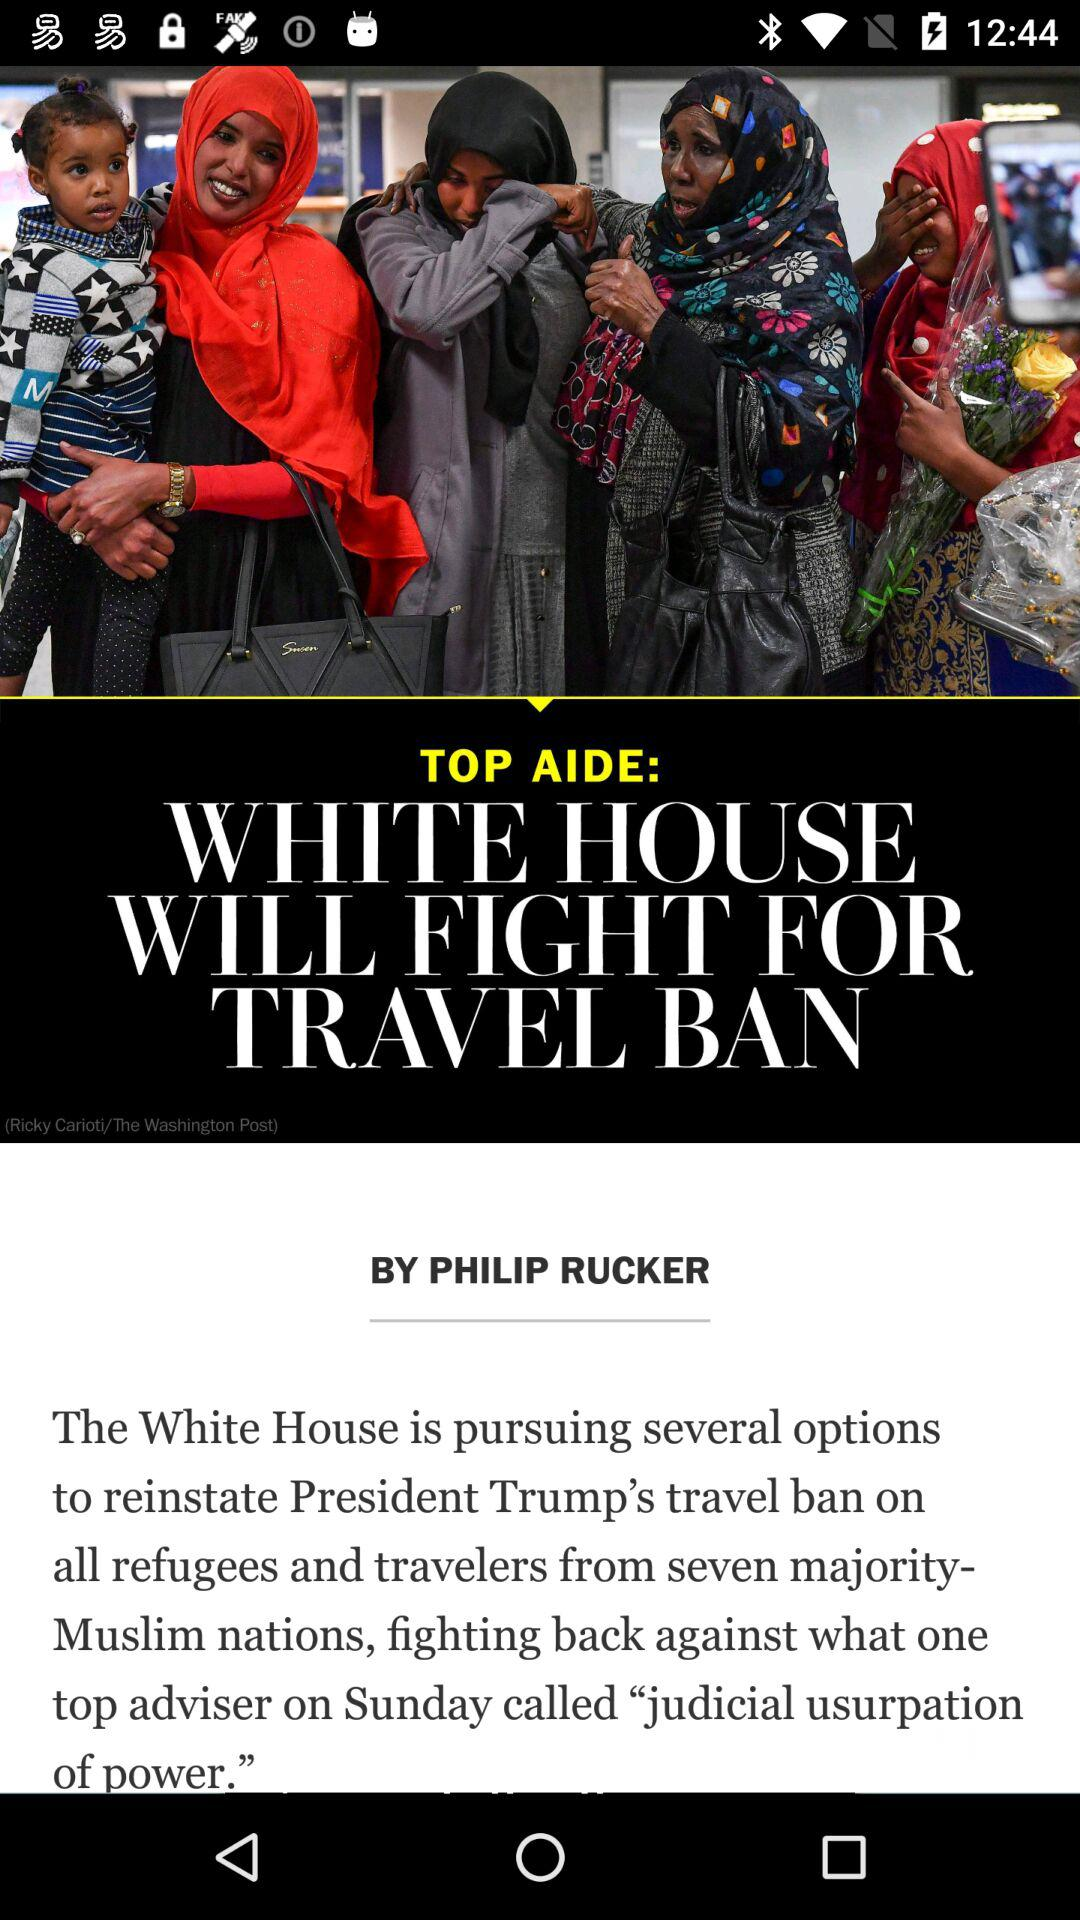When was the article published?
When the provided information is insufficient, respond with <no answer>. <no answer> 